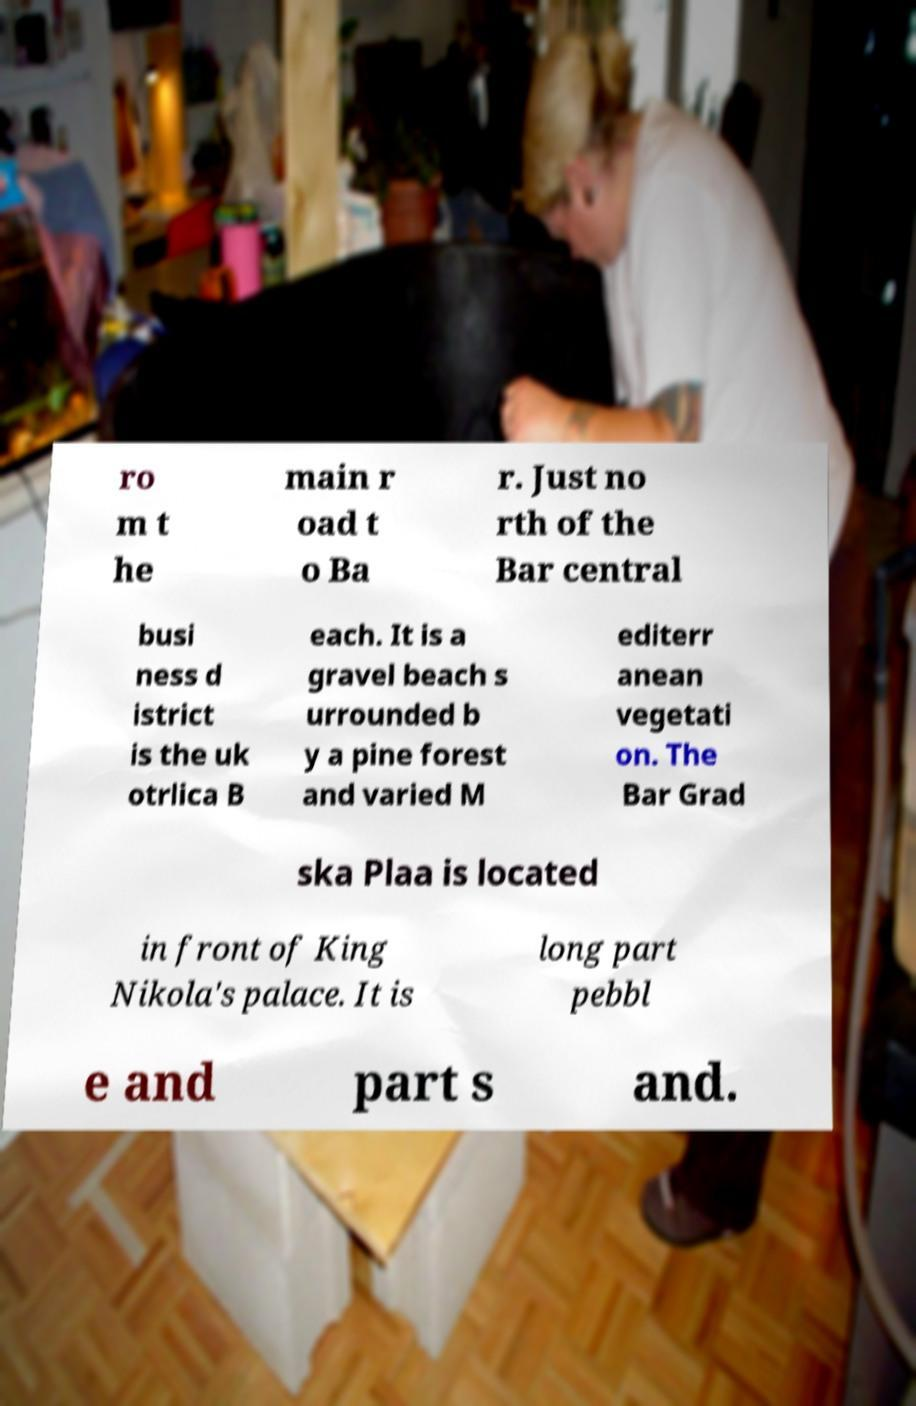Could you assist in decoding the text presented in this image and type it out clearly? ro m t he main r oad t o Ba r. Just no rth of the Bar central busi ness d istrict is the uk otrlica B each. It is a gravel beach s urrounded b y a pine forest and varied M editerr anean vegetati on. The Bar Grad ska Plaa is located in front of King Nikola's palace. It is long part pebbl e and part s and. 